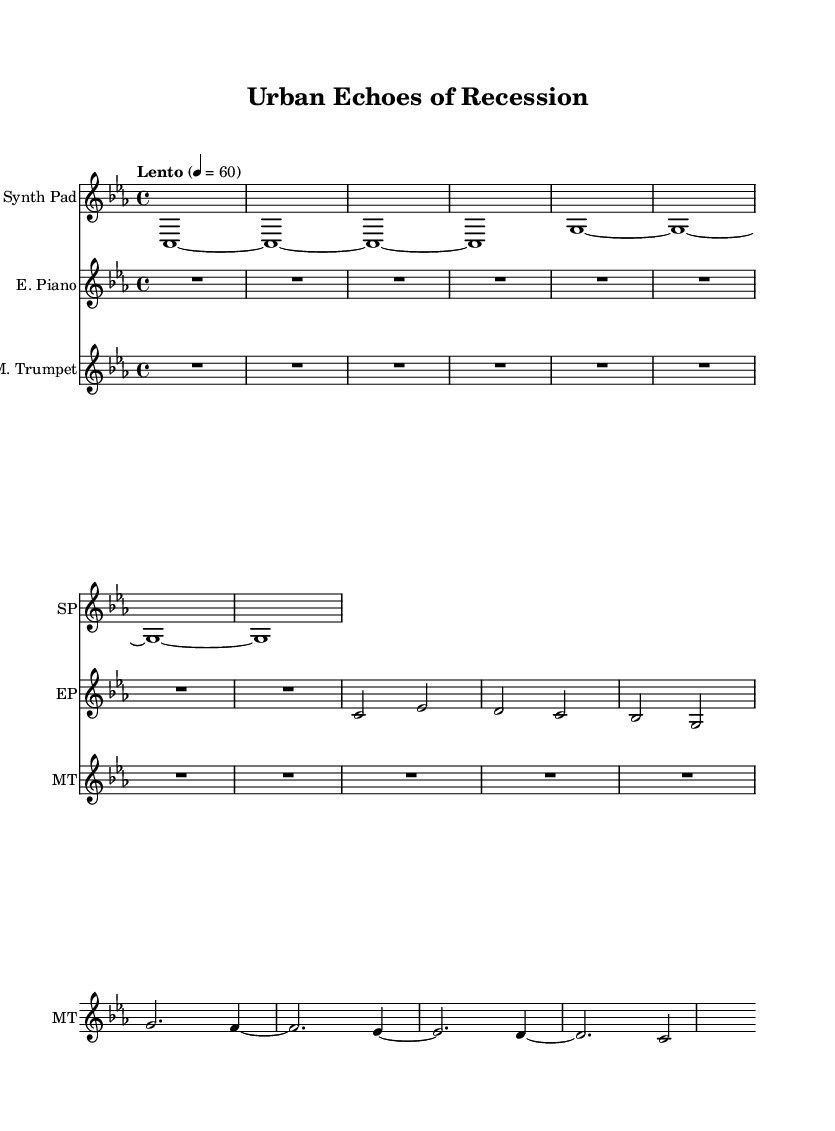What is the key signature of this music? The key signature is C minor, which is indicated by three flats in the key signature.
Answer: C minor What is the time signature of the piece? The time signature is 4/4, which means there are four beats in each measure and the quarter note gets one beat.
Answer: 4/4 What is the tempo marking for this composition? The tempo marking is "Lento", which indicates a slow tempo, typically around 60 beats per minute.
Answer: Lento How many measures does the Synth Pad part have? The Synth Pad part has 8 measures, counting the spaces between the bar lines in the notation.
Answer: 8 measures Which instrument has a rest at the beginning of the score? The Electric Piano has a rest at the beginning, indicated by the "R" notation followed by the duration.
Answer: Electric Piano What does the muted trumpet section signify about the mood of the piece? The muted trumpet section, characterized by a softer, more subdued sound, likely contributes to an atmospheric and introspective mood reflecting the theme of financial downturn.
Answer: Atmospheric How does the harmonic structure of the piece reflect the inspiration from financial downturns? The harmonic structure in C minor provides a melancholic tone, while the soft, sustained notes from both the Synth Pad and Electric Piano convey a sense of reflection and contemplation, which evokes feelings associated with economic challenges.
Answer: Melancholic tone 